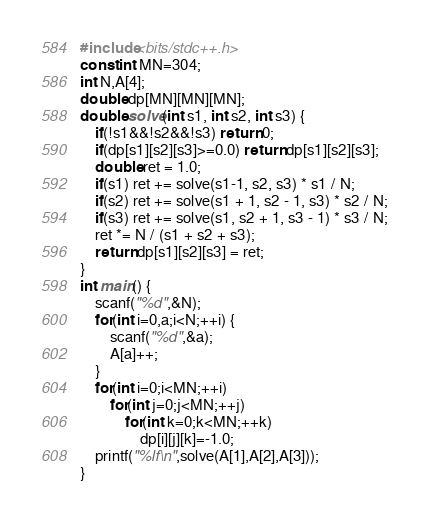Convert code to text. <code><loc_0><loc_0><loc_500><loc_500><_C++_>#include<bits/stdc++.h>
const int MN=304;
int N,A[4];
double dp[MN][MN][MN];
double solve(int s1, int s2, int s3) {
    if(!s1&&!s2&&!s3) return 0;
    if(dp[s1][s2][s3]>=0.0) return dp[s1][s2][s3];
    double ret = 1.0;
    if(s1) ret += solve(s1-1, s2, s3) * s1 / N;
    if(s2) ret += solve(s1 + 1, s2 - 1, s3) * s2 / N;
    if(s3) ret += solve(s1, s2 + 1, s3 - 1) * s3 / N;
    ret *= N / (s1 + s2 + s3);
    return dp[s1][s2][s3] = ret;
}
int main() {
    scanf("%d",&N);
    for(int i=0,a;i<N;++i) {
        scanf("%d",&a);
        A[a]++;
    }
    for(int i=0;i<MN;++i)
        for(int j=0;j<MN;++j)
            for(int k=0;k<MN;++k)
                dp[i][j][k]=-1.0;
    printf("%lf\n",solve(A[1],A[2],A[3]));
}
</code> 